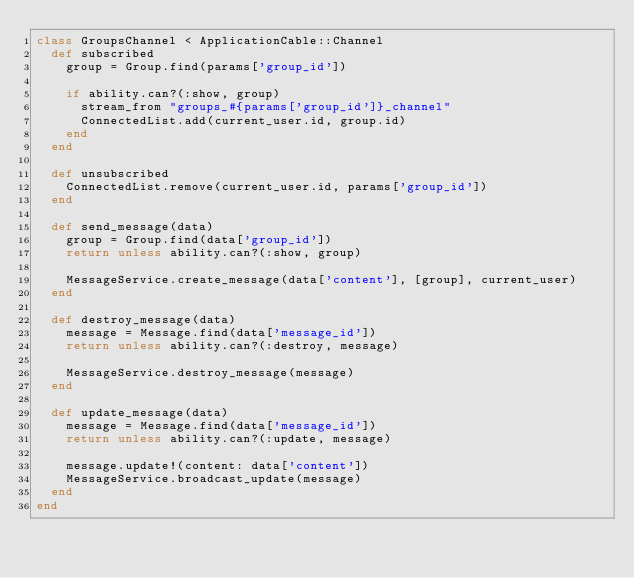Convert code to text. <code><loc_0><loc_0><loc_500><loc_500><_Ruby_>class GroupsChannel < ApplicationCable::Channel
  def subscribed
    group = Group.find(params['group_id'])

    if ability.can?(:show, group)
      stream_from "groups_#{params['group_id']}_channel"
      ConnectedList.add(current_user.id, group.id)
    end
  end

  def unsubscribed
    ConnectedList.remove(current_user.id, params['group_id'])
  end

  def send_message(data)
    group = Group.find(data['group_id'])
    return unless ability.can?(:show, group)

    MessageService.create_message(data['content'], [group], current_user)
  end

  def destroy_message(data)
    message = Message.find(data['message_id'])
    return unless ability.can?(:destroy, message)

    MessageService.destroy_message(message)
  end

  def update_message(data)
    message = Message.find(data['message_id'])
    return unless ability.can?(:update, message)

    message.update!(content: data['content'])
    MessageService.broadcast_update(message)
  end
end
</code> 